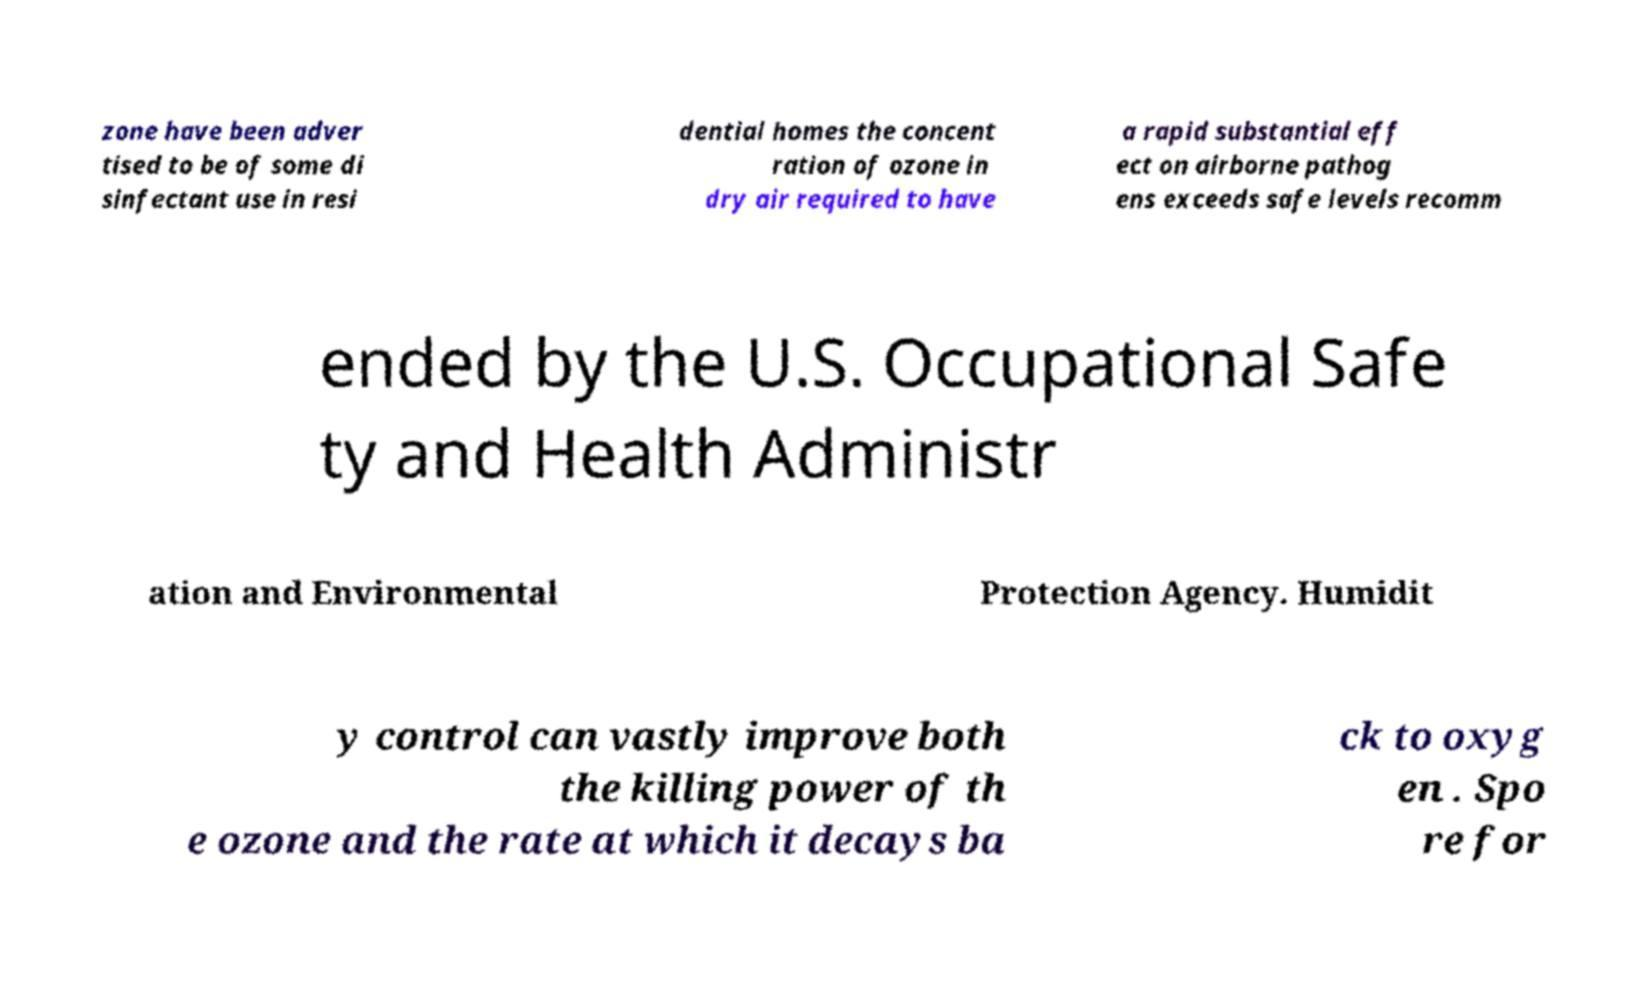Could you assist in decoding the text presented in this image and type it out clearly? zone have been adver tised to be of some di sinfectant use in resi dential homes the concent ration of ozone in dry air required to have a rapid substantial eff ect on airborne pathog ens exceeds safe levels recomm ended by the U.S. Occupational Safe ty and Health Administr ation and Environmental Protection Agency. Humidit y control can vastly improve both the killing power of th e ozone and the rate at which it decays ba ck to oxyg en . Spo re for 